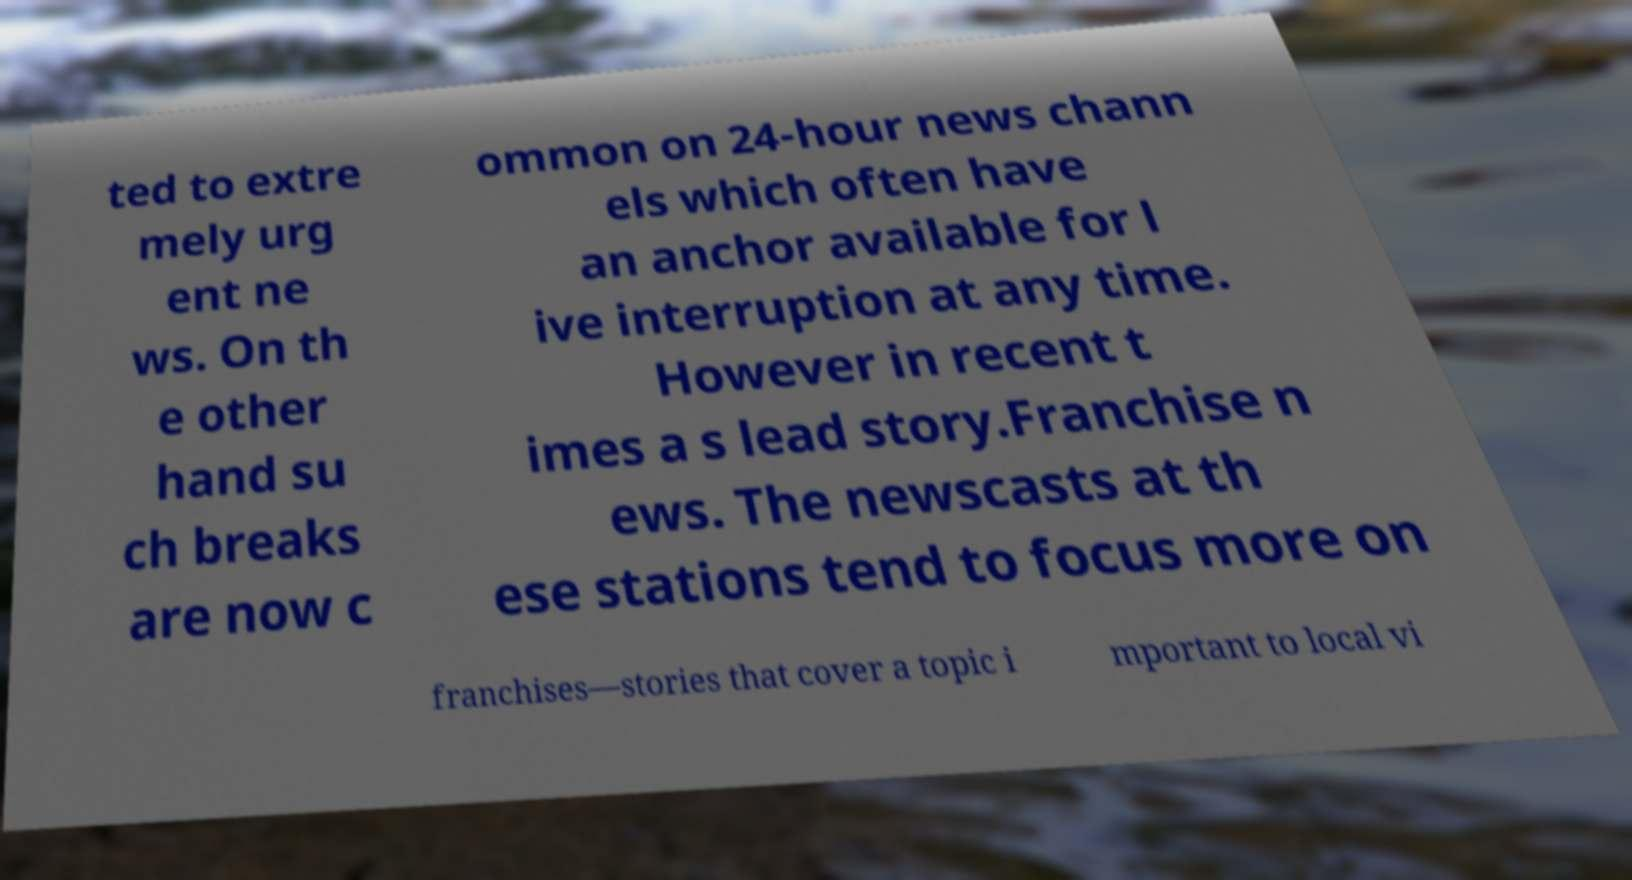There's text embedded in this image that I need extracted. Can you transcribe it verbatim? ted to extre mely urg ent ne ws. On th e other hand su ch breaks are now c ommon on 24-hour news chann els which often have an anchor available for l ive interruption at any time. However in recent t imes a s lead story.Franchise n ews. The newscasts at th ese stations tend to focus more on franchises—stories that cover a topic i mportant to local vi 